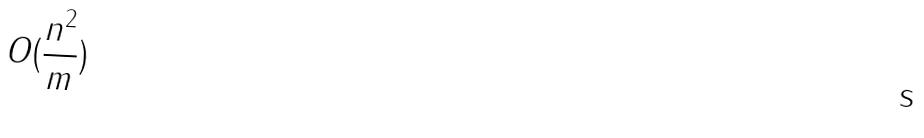<formula> <loc_0><loc_0><loc_500><loc_500>O ( \frac { n ^ { 2 } } { m } )</formula> 